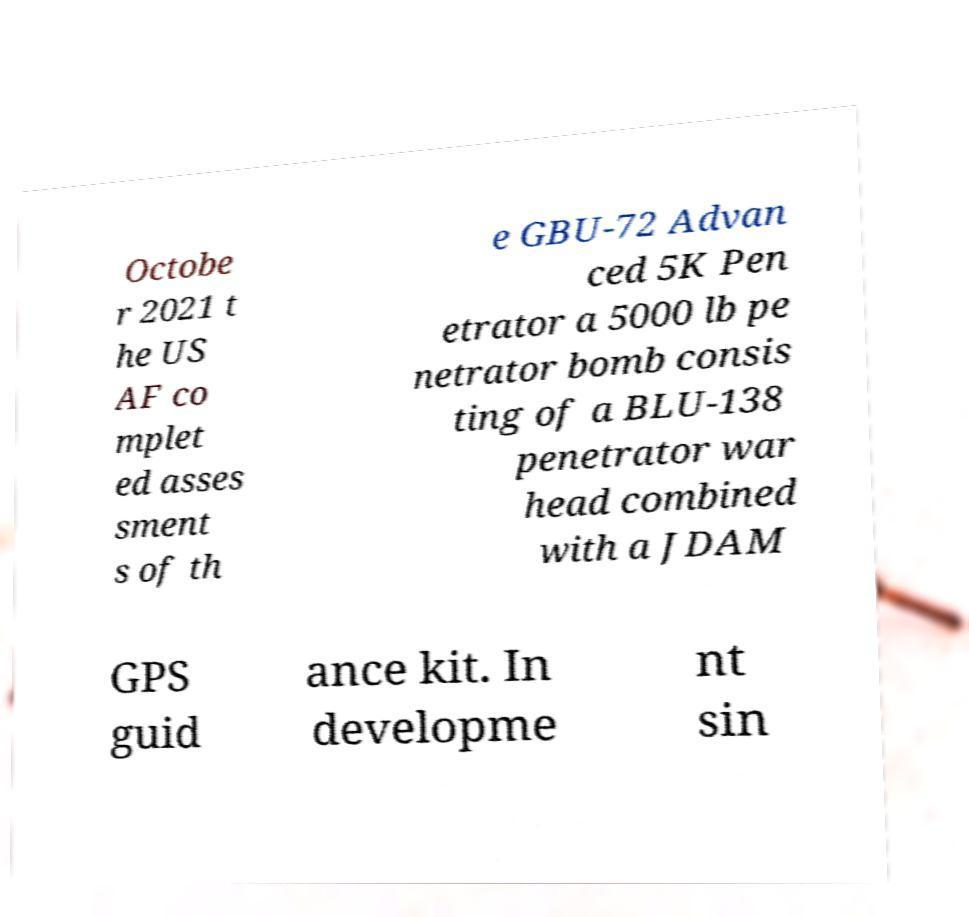I need the written content from this picture converted into text. Can you do that? Octobe r 2021 t he US AF co mplet ed asses sment s of th e GBU-72 Advan ced 5K Pen etrator a 5000 lb pe netrator bomb consis ting of a BLU-138 penetrator war head combined with a JDAM GPS guid ance kit. In developme nt sin 